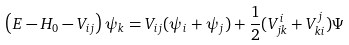<formula> <loc_0><loc_0><loc_500><loc_500>\left ( E - H _ { 0 } - V _ { i j } \right ) \psi _ { k } = V _ { i j } ( \psi _ { i } + \psi _ { j } ) + \frac { 1 } { 2 } ( V _ { j k } ^ { i } + V _ { k i } ^ { j } ) \Psi</formula> 